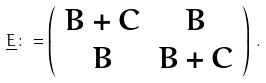<formula> <loc_0><loc_0><loc_500><loc_500>\underline { E } \colon = \left ( \begin{array} { c c } B + C & B \\ B & B + C \end{array} \right ) \, .</formula> 